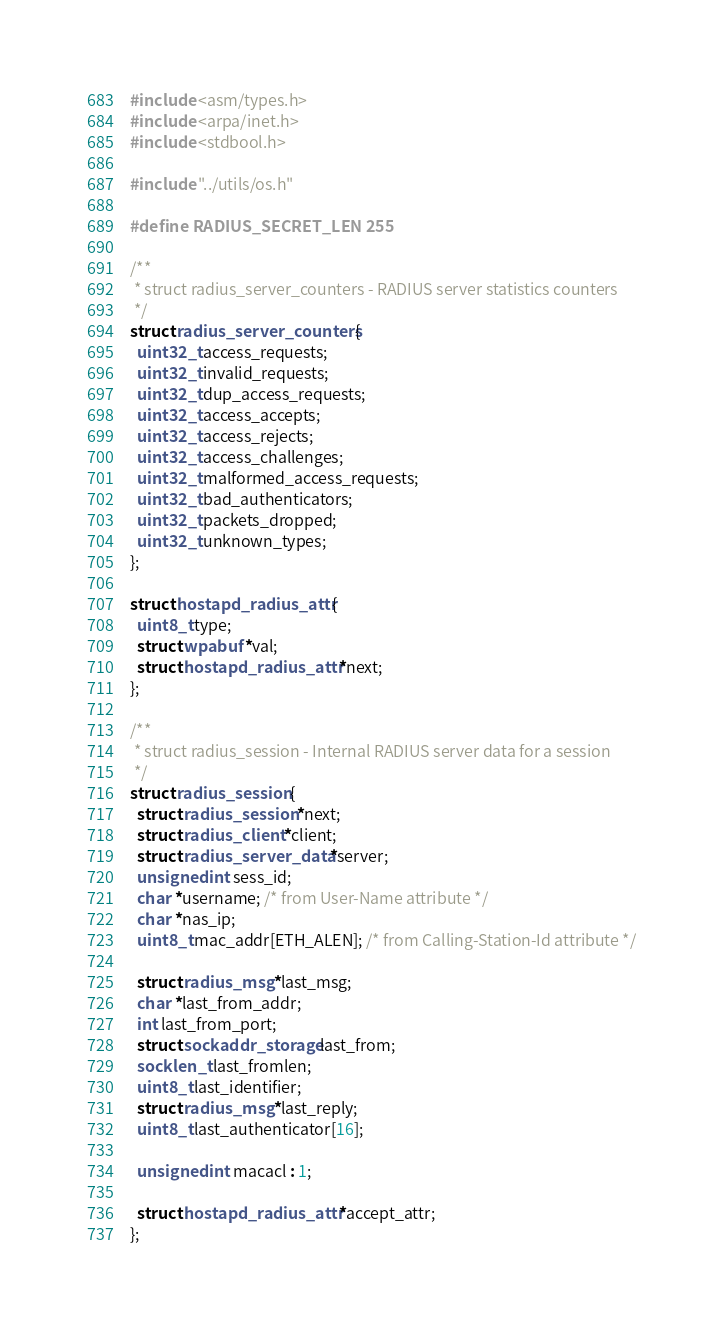Convert code to text. <code><loc_0><loc_0><loc_500><loc_500><_C_>#include <asm/types.h>
#include <arpa/inet.h>
#include <stdbool.h>

#include "../utils/os.h"

#define RADIUS_SECRET_LEN 255

/**
 * struct radius_server_counters - RADIUS server statistics counters
 */
struct radius_server_counters {
  uint32_t access_requests;
  uint32_t invalid_requests;
  uint32_t dup_access_requests;
  uint32_t access_accepts;
  uint32_t access_rejects;
  uint32_t access_challenges;
  uint32_t malformed_access_requests;
  uint32_t bad_authenticators;
  uint32_t packets_dropped;
  uint32_t unknown_types;
};

struct hostapd_radius_attr {
  uint8_t type;
  struct wpabuf *val;
  struct hostapd_radius_attr *next;
};

/**
 * struct radius_session - Internal RADIUS server data for a session
 */
struct radius_session {
  struct radius_session *next;
  struct radius_client *client;
  struct radius_server_data *server;
  unsigned int sess_id;
  char *username; /* from User-Name attribute */
  char *nas_ip;
  uint8_t mac_addr[ETH_ALEN]; /* from Calling-Station-Id attribute */

  struct radius_msg *last_msg;
  char *last_from_addr;
  int last_from_port;
  struct sockaddr_storage last_from;
  socklen_t last_fromlen;
  uint8_t last_identifier;
  struct radius_msg *last_reply;
  uint8_t last_authenticator[16];

  unsigned int macacl : 1;

  struct hostapd_radius_attr *accept_attr;
};
</code> 